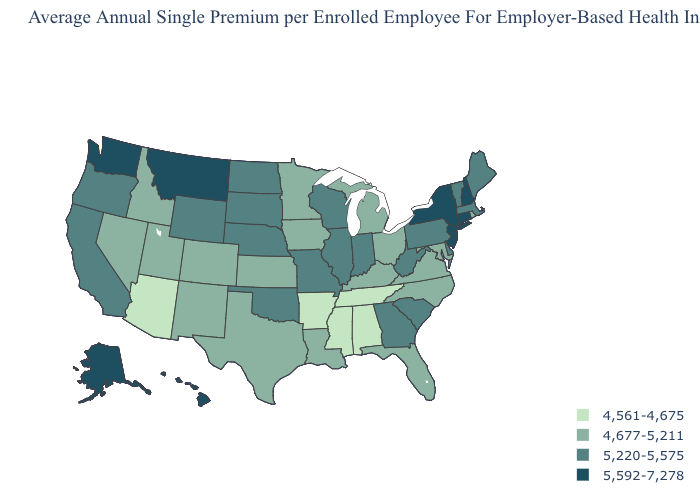What is the value of North Dakota?
Give a very brief answer. 5,220-5,575. Which states have the lowest value in the MidWest?
Give a very brief answer. Iowa, Kansas, Michigan, Minnesota, Ohio. Which states have the highest value in the USA?
Be succinct. Alaska, Connecticut, Hawaii, Montana, New Hampshire, New Jersey, New York, Washington. Name the states that have a value in the range 5,220-5,575?
Short answer required. California, Delaware, Georgia, Illinois, Indiana, Maine, Massachusetts, Missouri, Nebraska, North Dakota, Oklahoma, Oregon, Pennsylvania, South Carolina, South Dakota, Vermont, West Virginia, Wisconsin, Wyoming. Among the states that border Arizona , does Nevada have the lowest value?
Quick response, please. Yes. Which states have the lowest value in the USA?
Give a very brief answer. Alabama, Arizona, Arkansas, Mississippi, Tennessee. Does South Carolina have a higher value than Nebraska?
Keep it brief. No. What is the highest value in the Northeast ?
Give a very brief answer. 5,592-7,278. Does Arizona have the lowest value in the West?
Write a very short answer. Yes. Does Arkansas have the lowest value in the USA?
Be succinct. Yes. Does Kentucky have the highest value in the USA?
Answer briefly. No. Which states have the lowest value in the USA?
Quick response, please. Alabama, Arizona, Arkansas, Mississippi, Tennessee. Among the states that border Georgia , does Alabama have the lowest value?
Answer briefly. Yes. What is the lowest value in states that border Wyoming?
Be succinct. 4,677-5,211. Does Alabama have the lowest value in the USA?
Write a very short answer. Yes. 